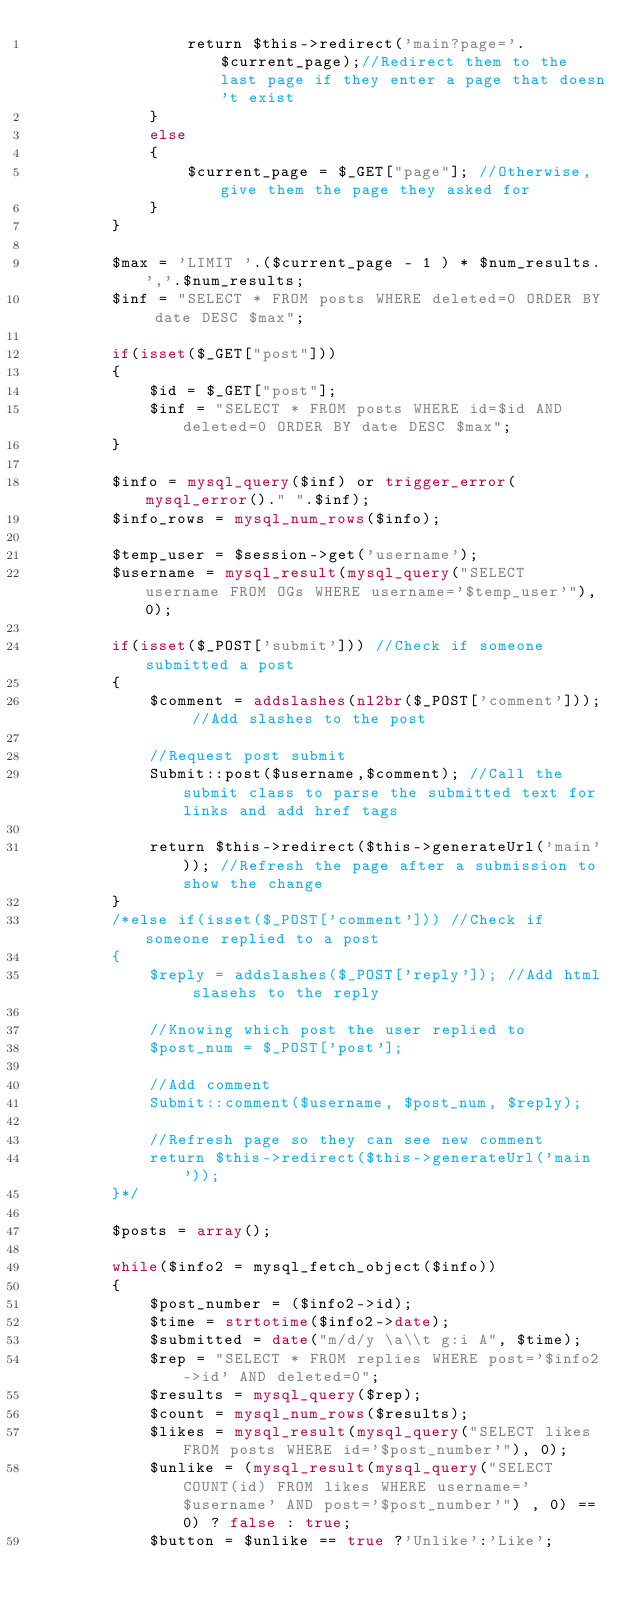<code> <loc_0><loc_0><loc_500><loc_500><_PHP_>				return $this->redirect('main?page='.$current_page);//Redirect them to the last page if they enter a page that doesn't exist
	    	}
    		else
    		{
    			$current_page = $_GET["page"]; //Otherwise, give them the page they asked for
    		}
    	}
        
        $max = 'LIMIT '.($current_page - 1 ) * $num_results.','.$num_results; 
        $inf = "SELECT * FROM posts WHERE deleted=0 ORDER BY date DESC $max";
        
        if(isset($_GET["post"]))
    	{
            $id = $_GET["post"];
            $inf = "SELECT * FROM posts WHERE id=$id AND deleted=0 ORDER BY date DESC $max";
    	}
        
        $info = mysql_query($inf) or trigger_error(mysql_error()." ".$inf); 
        $info_rows = mysql_num_rows($info);
        
        $temp_user = $session->get('username');
        $username = mysql_result(mysql_query("SELECT username FROM OGs WHERE username='$temp_user'"), 0);
        
        if(isset($_POST['submit'])) //Check if someone submitted a post
    	{ 
    		$comment = addslashes(nl2br($_POST['comment'])); //Add slashes to the post 
	
    		//Request post submit
    		Submit::post($username,$comment); //Call the submit class to parse the submitted text for links and add href tags

    		return $this->redirect($this->generateUrl('main')); //Refresh the page after a submission to show the change
    	} 
    	/*else if(isset($_POST['comment'])) //Check if someone replied to a post
    	{ 
    		$reply = addslashes($_POST['reply']); //Add html slasehs to the reply
	
    		//Knowing which post the user replied to
    		$post_num = $_POST['post']; 
	
    		//Add comment 
    		Submit::comment($username, $post_num, $reply);

    		//Refresh page so they can see new comment 
    		return $this->redirect($this->generateUrl('main'));
    	}*/
        
        $posts = array();
        
        while($info2 = mysql_fetch_object($info))
        {
            $post_number = ($info2->id);
            $time = strtotime($info2->date);
            $submitted = date("m/d/y \a\\t g:i A", $time);
            $rep = "SELECT * FROM replies WHERE post='$info2->id' AND deleted=0";
            $results = mysql_query($rep);
            $count = mysql_num_rows($results);
            $likes = mysql_result(mysql_query("SELECT likes FROM posts WHERE id='$post_number'"), 0);
            $unlike = (mysql_result(mysql_query("SELECT COUNT(id) FROM likes WHERE username='$username' AND post='$post_number'") , 0) == 0) ? false : true;
            $button = $unlike == true ?'Unlike':'Like';</code> 